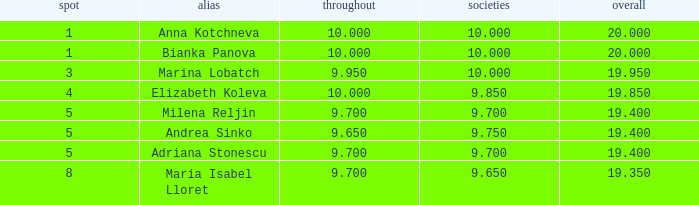What are the lowest clubs that have a place greater than 5, with an all around greater than 9.7? None. 